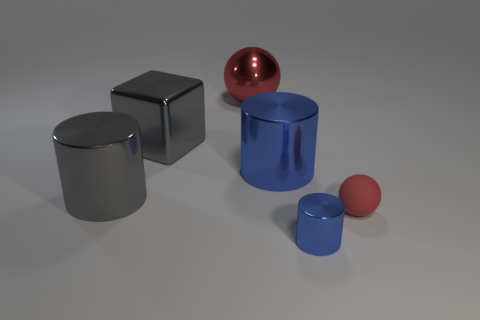Subtract all gray metal cylinders. How many cylinders are left? 2 Subtract all yellow blocks. How many blue cylinders are left? 2 Add 3 cylinders. How many objects exist? 9 Subtract all blue cylinders. How many cylinders are left? 1 Subtract all blocks. How many objects are left? 5 Add 3 small red spheres. How many small red spheres are left? 4 Add 5 brown rubber cylinders. How many brown rubber cylinders exist? 5 Subtract 0 green balls. How many objects are left? 6 Subtract all green spheres. Subtract all yellow blocks. How many spheres are left? 2 Subtract all shiny things. Subtract all tiny brown shiny objects. How many objects are left? 1 